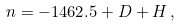Convert formula to latex. <formula><loc_0><loc_0><loc_500><loc_500>n = - 1 4 6 2 . 5 + D + H \, ,</formula> 